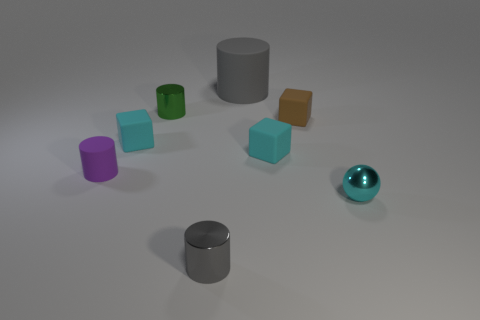There is a shiny cylinder that is the same color as the large rubber cylinder; what size is it?
Give a very brief answer. Small. There is a object that is the same color as the big matte cylinder; what shape is it?
Offer a terse response. Cylinder. How many purple things are tiny metallic cylinders or tiny metal spheres?
Keep it short and to the point. 0. Is there anything else that has the same material as the big gray object?
Offer a very short reply. Yes. There is a big object that is the same shape as the tiny green thing; what is it made of?
Give a very brief answer. Rubber. Are there the same number of tiny rubber cylinders on the right side of the small brown thing and big things?
Offer a very short reply. No. What size is the thing that is both to the left of the tiny green cylinder and right of the purple rubber thing?
Offer a very short reply. Small. Is there anything else of the same color as the tiny ball?
Offer a very short reply. Yes. There is a matte cube that is on the left side of the small object in front of the small cyan sphere; how big is it?
Provide a short and direct response. Small. There is a small rubber thing that is both behind the purple rubber cylinder and on the left side of the small green cylinder; what color is it?
Provide a short and direct response. Cyan. 